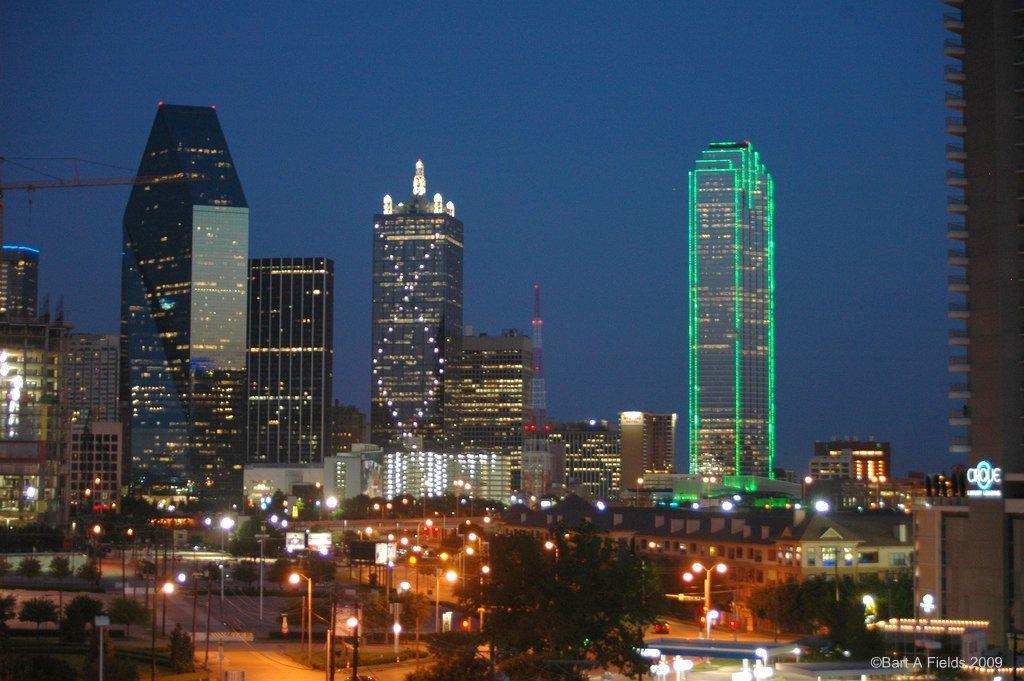In one or two sentences, can you explain what this image depicts? In this image, we can see buildings, towers, lights, poles, boards, trees and we can see some vehicles on the road. At the bottom, there is some text. At the top, there is sky. 